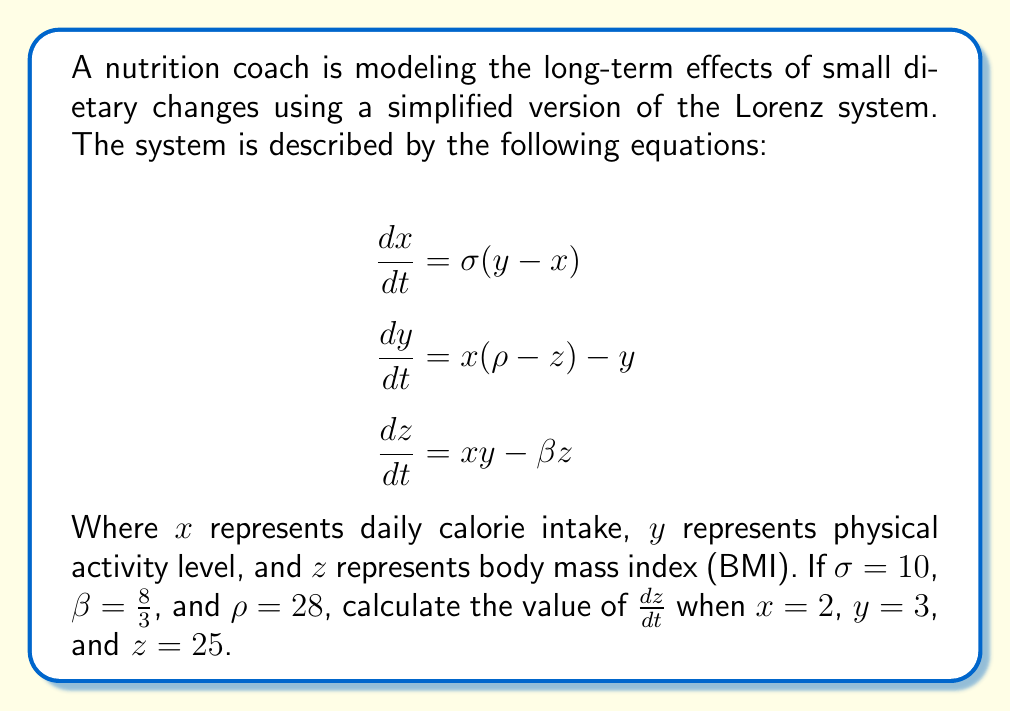What is the answer to this math problem? To solve this problem, we'll follow these steps:

1. Identify the equation for $\frac{dz}{dt}$ from the given system:
   $$\frac{dz}{dt} = xy - \beta z$$

2. Substitute the given values:
   $x = 2$
   $y = 3$
   $z = 25$
   $\beta = \frac{8}{3}$

3. Calculate $xy$:
   $xy = 2 * 3 = 6$

4. Calculate $\beta z$:
   $\beta z = \frac{8}{3} * 25 = \frac{200}{3}$

5. Substitute these values into the equation:
   $$\frac{dz}{dt} = 6 - \frac{200}{3}$$

6. Simplify the fraction:
   $$\frac{dz}{dt} = \frac{18}{3} - \frac{200}{3} = \frac{18 - 200}{3} = \frac{-182}{3}$$

7. Calculate the final result:
   $$\frac{dz}{dt} = -60\frac{2}{3}$$

This result indicates that under these specific conditions, the BMI is decreasing at a rate of approximately 60.67 units per time step, demonstrating how small changes in calorie intake and physical activity can lead to significant changes in BMI over time, illustrating the butterfly effect in the context of dietary changes and health outcomes.
Answer: $-60\frac{2}{3}$ 